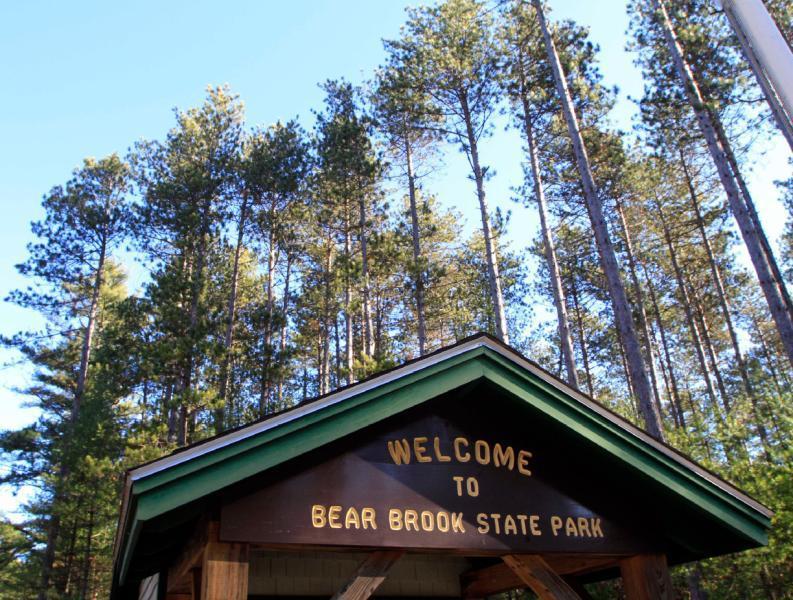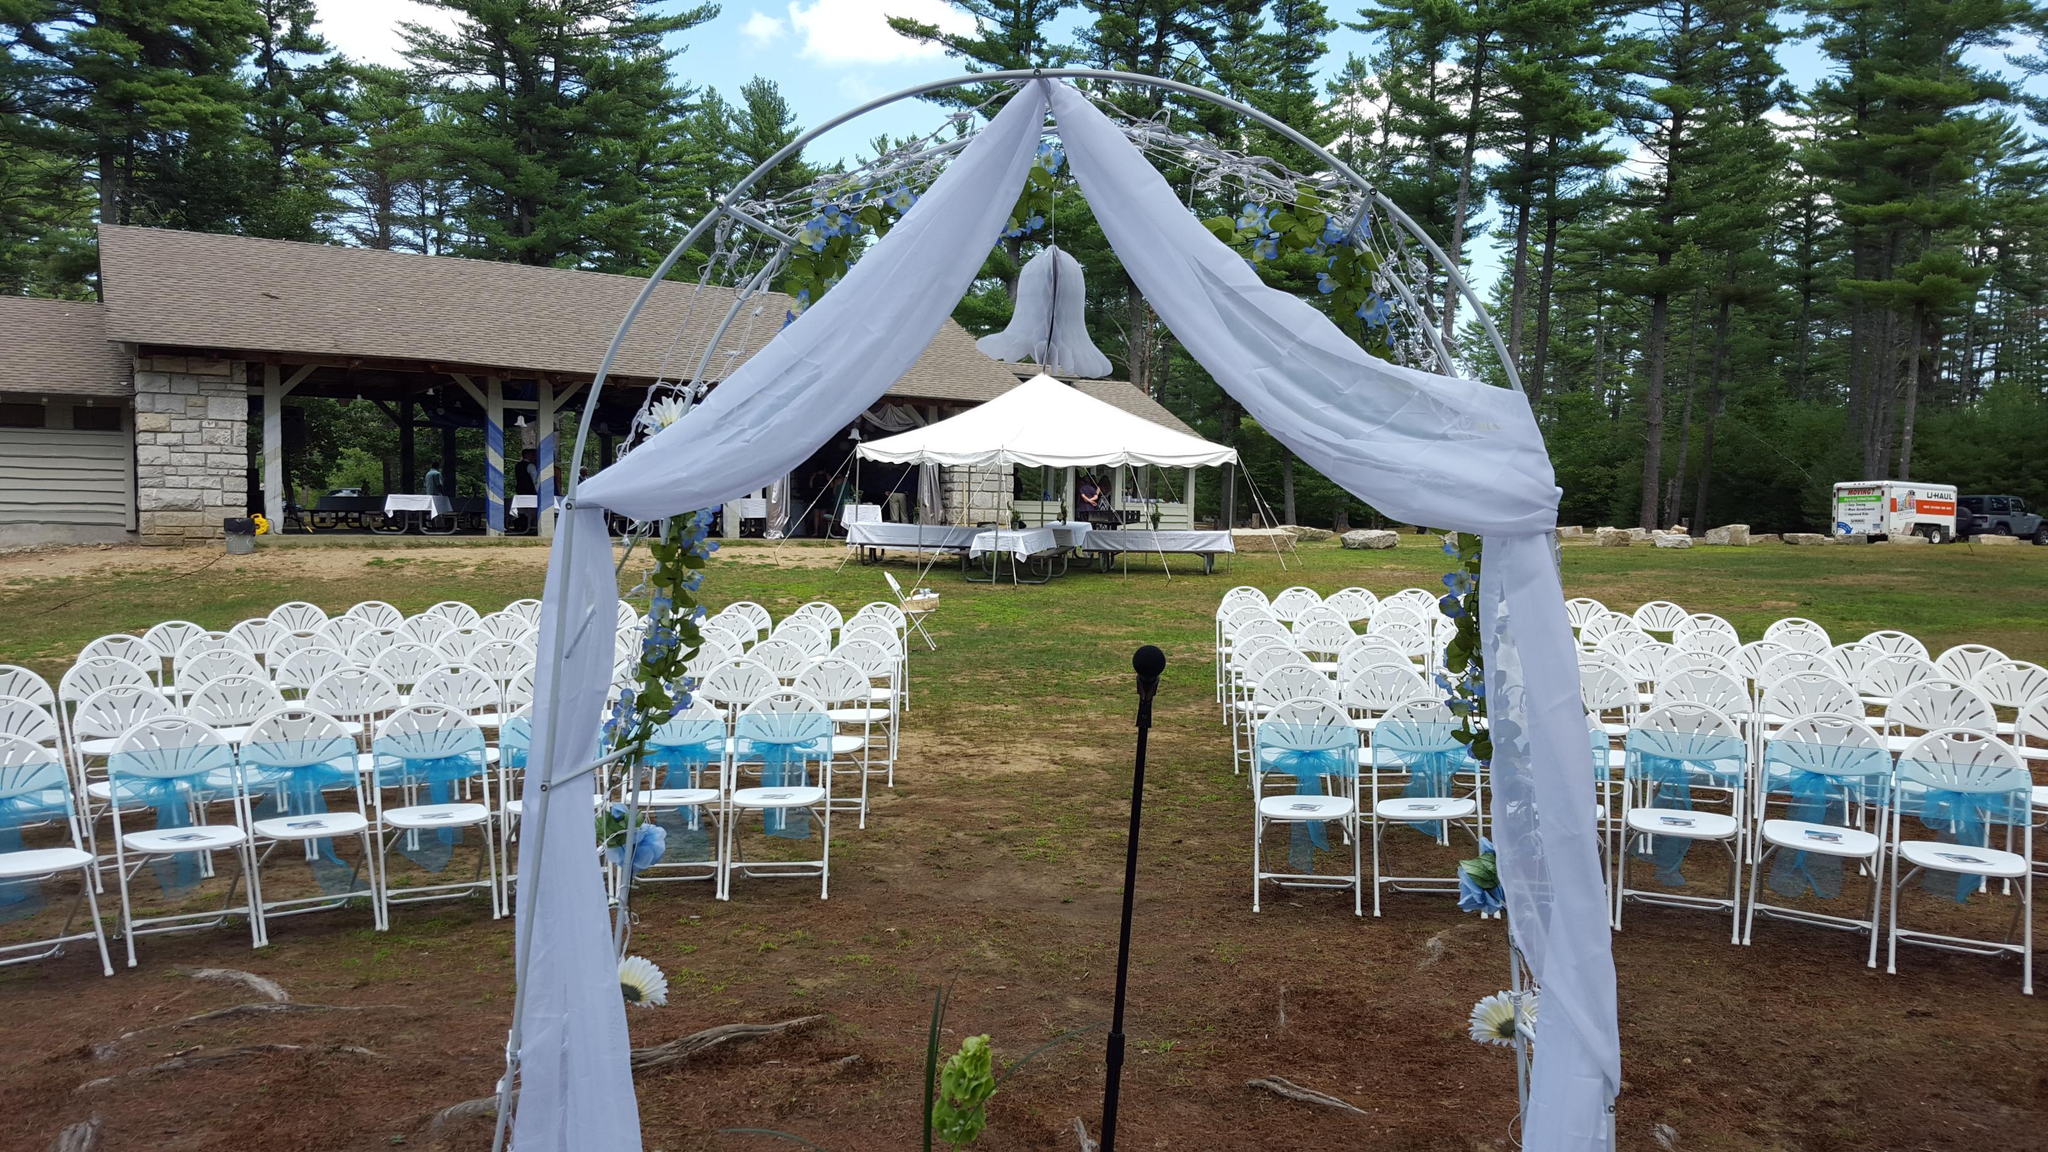The first image is the image on the left, the second image is the image on the right. For the images shown, is this caption "There is a two story event house nestled into the wood looking over a beach." true? Answer yes or no. No. The first image is the image on the left, the second image is the image on the right. For the images shown, is this caption "An image shows a gray stone building with a straight peaked gray roof in front of a stretch of beach on a lake." true? Answer yes or no. No. 